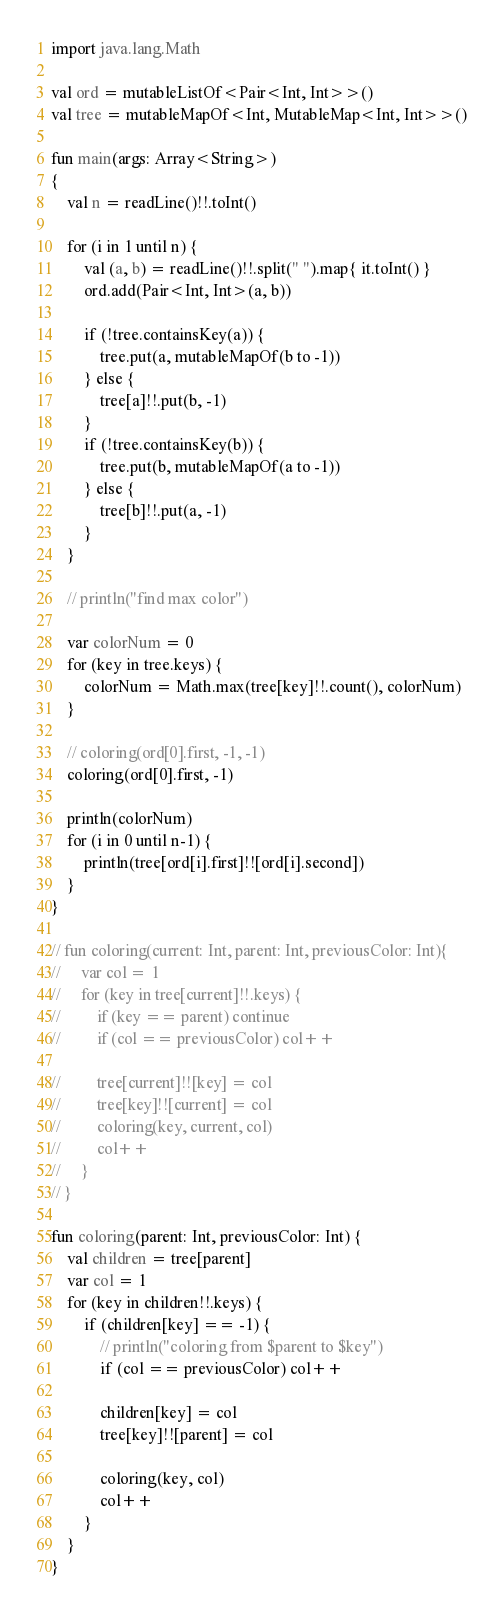<code> <loc_0><loc_0><loc_500><loc_500><_Kotlin_>import java.lang.Math

val ord = mutableListOf<Pair<Int, Int>>()
val tree = mutableMapOf<Int, MutableMap<Int, Int>>()

fun main(args: Array<String>)
{
    val n = readLine()!!.toInt()

    for (i in 1 until n) {
        val (a, b) = readLine()!!.split(" ").map{ it.toInt() }
        ord.add(Pair<Int, Int>(a, b))

        if (!tree.containsKey(a)) {
            tree.put(a, mutableMapOf(b to -1))
        } else {
            tree[a]!!.put(b, -1)
        }
        if (!tree.containsKey(b)) {
            tree.put(b, mutableMapOf(a to -1))
        } else {
            tree[b]!!.put(a, -1)
        }
    }

    // println("find max color")

    var colorNum = 0
    for (key in tree.keys) {
        colorNum = Math.max(tree[key]!!.count(), colorNum)
    }

    // coloring(ord[0].first, -1, -1)
    coloring(ord[0].first, -1)

    println(colorNum)
    for (i in 0 until n-1) {
        println(tree[ord[i].first]!![ord[i].second])
    }
}

// fun coloring(current: Int, parent: Int, previousColor: Int){
//     var col = 1
//     for (key in tree[current]!!.keys) {
//         if (key == parent) continue
//         if (col == previousColor) col++

//         tree[current]!![key] = col
//         tree[key]!![current] = col
//         coloring(key, current, col)
//         col++
//     }
// }

fun coloring(parent: Int, previousColor: Int) {
    val children = tree[parent]
    var col = 1
    for (key in children!!.keys) {
        if (children[key] == -1) {
            // println("coloring from $parent to $key")
            if (col == previousColor) col++

            children[key] = col
            tree[key]!![parent] = col

            coloring(key, col)
            col++
        }
    }
}
</code> 